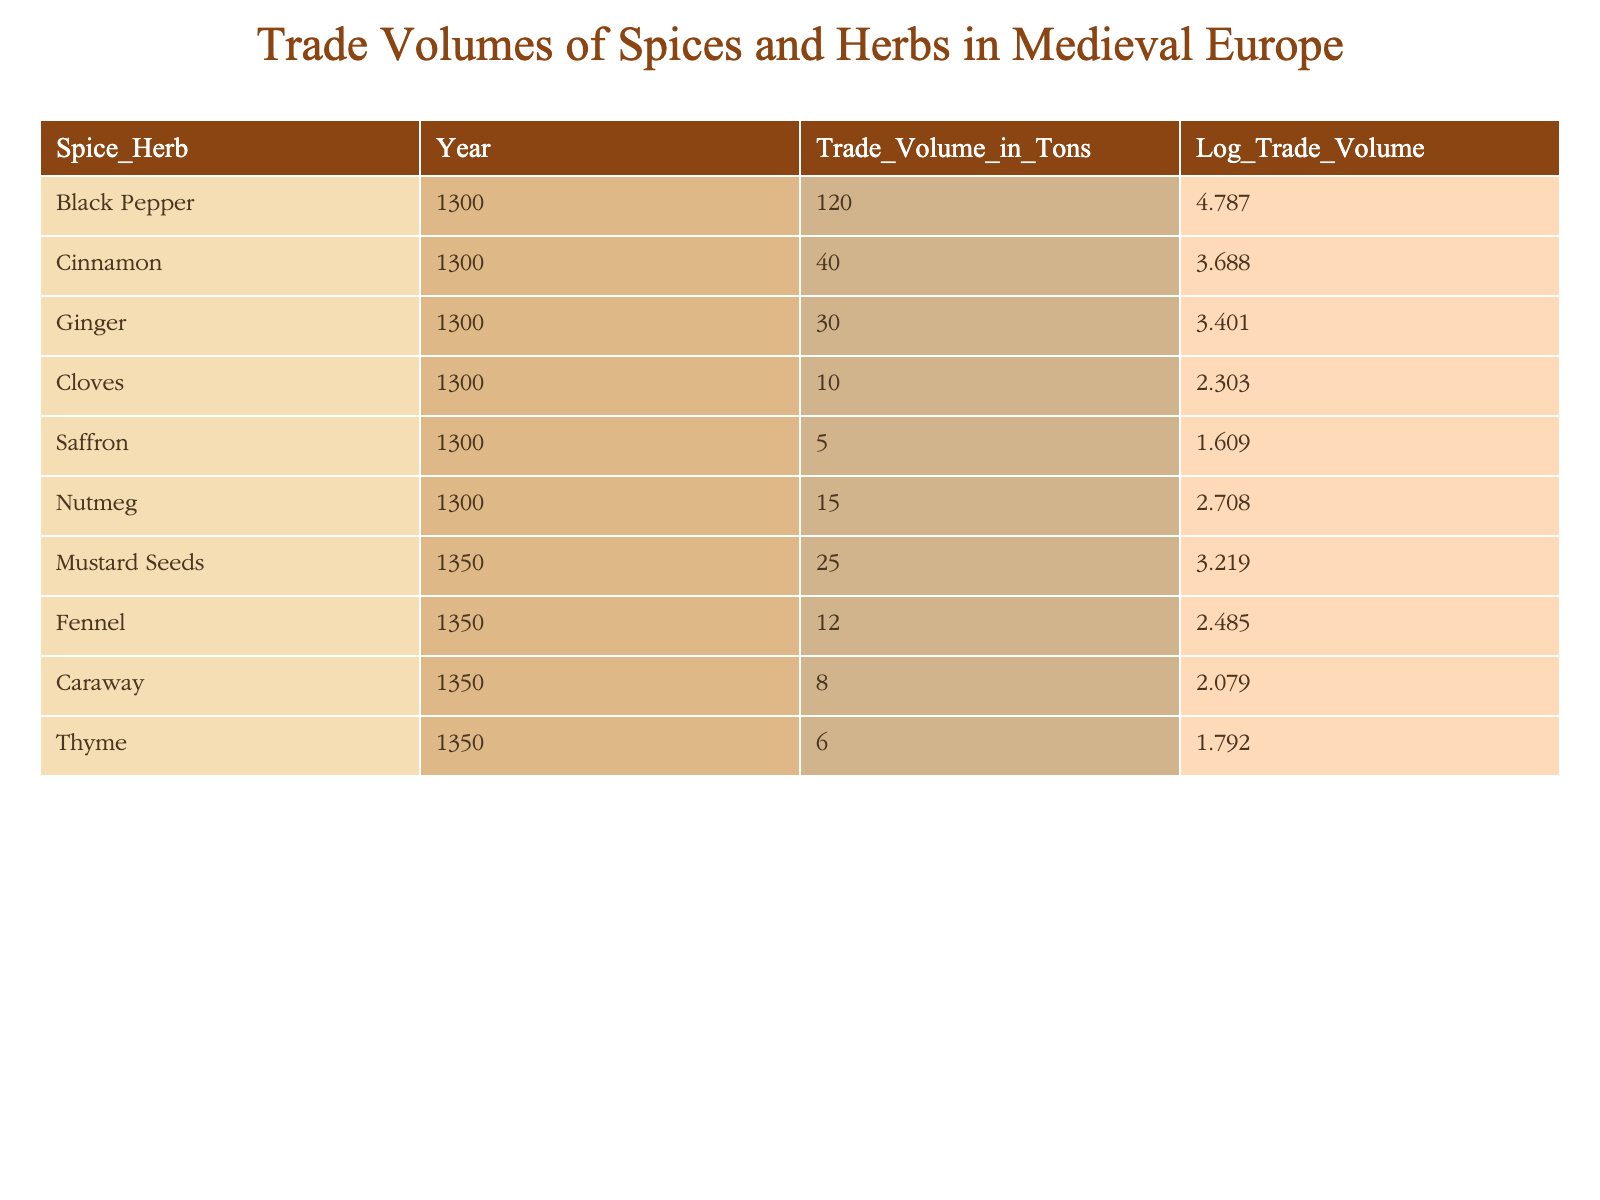What is the trade volume of Black Pepper in 1300? The table lists the trade volume of Black Pepper under the year 1300, which is directly stated as 120 tons.
Answer: 120 tons Which spice or herb has the highest trade volume in 1300? Looking at the trade volumes listed for the year 1300, Black Pepper has the highest value at 120 tons, compared to Cinnamon (40 tons), Ginger (30 tons), Cloves (10 tons), Saffron (5 tons), and Nutmeg (15 tons).
Answer: Black Pepper What is the total trade volume of spices and herbs in 1350? The trade volumes for 1350 are as follows: Mustard Seeds (25 tons), Fennel (12 tons), Caraway (8 tons), and Thyme (6 tons). Summing these values gives us a total of (25 + 12 + 8 + 6) = 51 tons.
Answer: 51 tons Is the trade volume of Saffron greater than that of Thyme in 1300? The table shows that Saffron has a trade volume of 5 tons, while Thyme in 1350 has a trade volume of 6 tons. Comparing these values, Saffron (5 tons) is less than Thyme (6 tons).
Answer: No What is the average trade volume of the spices and herbs listed for 1300? The trade volumes for 1300 are: Black Pepper (120 tons), Cinnamon (40 tons), Ginger (30 tons), Cloves (10 tons), Saffron (5 tons), and Nutmeg (15 tons). The sum is (120 + 40 + 30 + 10 + 5 + 15) = 220 tons. There are 6 values, so the average is 220 / 6 ≈ 36.67 tons.
Answer: 36.67 tons Which spice or herb has the lowest trade volume in 1350, and what is its value? From the data for 1350, the trade volumes are Mustard Seeds (25 tons), Fennel (12 tons), Caraway (8 tons), and Thyme (6 tons). The lowest is Thyme with a trade volume of 6 tons.
Answer: Thyme, 6 tons Did the trade volume of Ginger increase or decrease from 1300 to 1350? The data shows that Ginger had a trade volume of 30 tons in 1300 but is not listed for 1350. Thus, it is reasonable to conclude that its trade volume decreased (as it was not recorded).
Answer: Decrease What is the difference in trade volume between Mustard Seeds and Fennel in 1350? The trade volumes for Mustard Seeds is 25 tons and for Fennel is 12 tons. The difference can be calculated as (25 - 12) = 13 tons.
Answer: 13 tons 